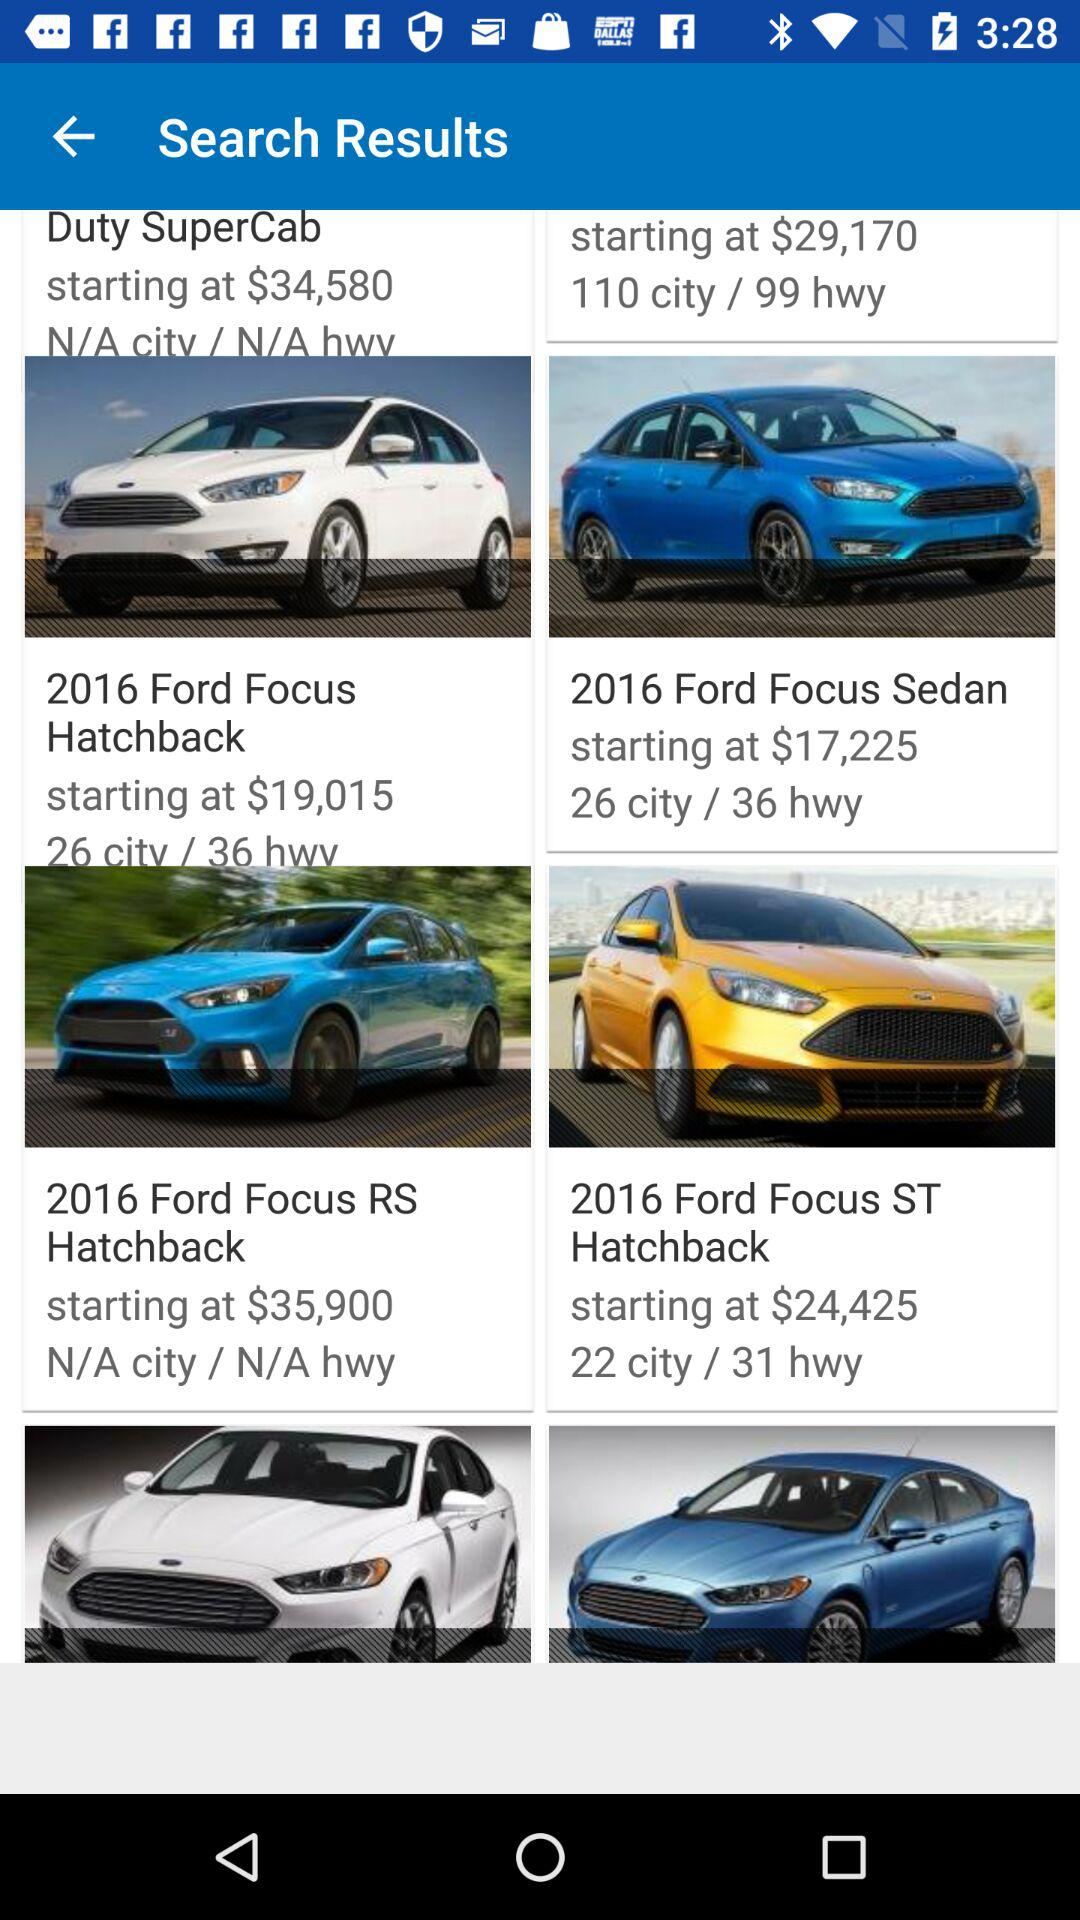What is the starting cost of the 2016 Ford Focus ST Hatchback? The starting cost of the 2016 Ford Focus ST Hatchback is $24,425. 